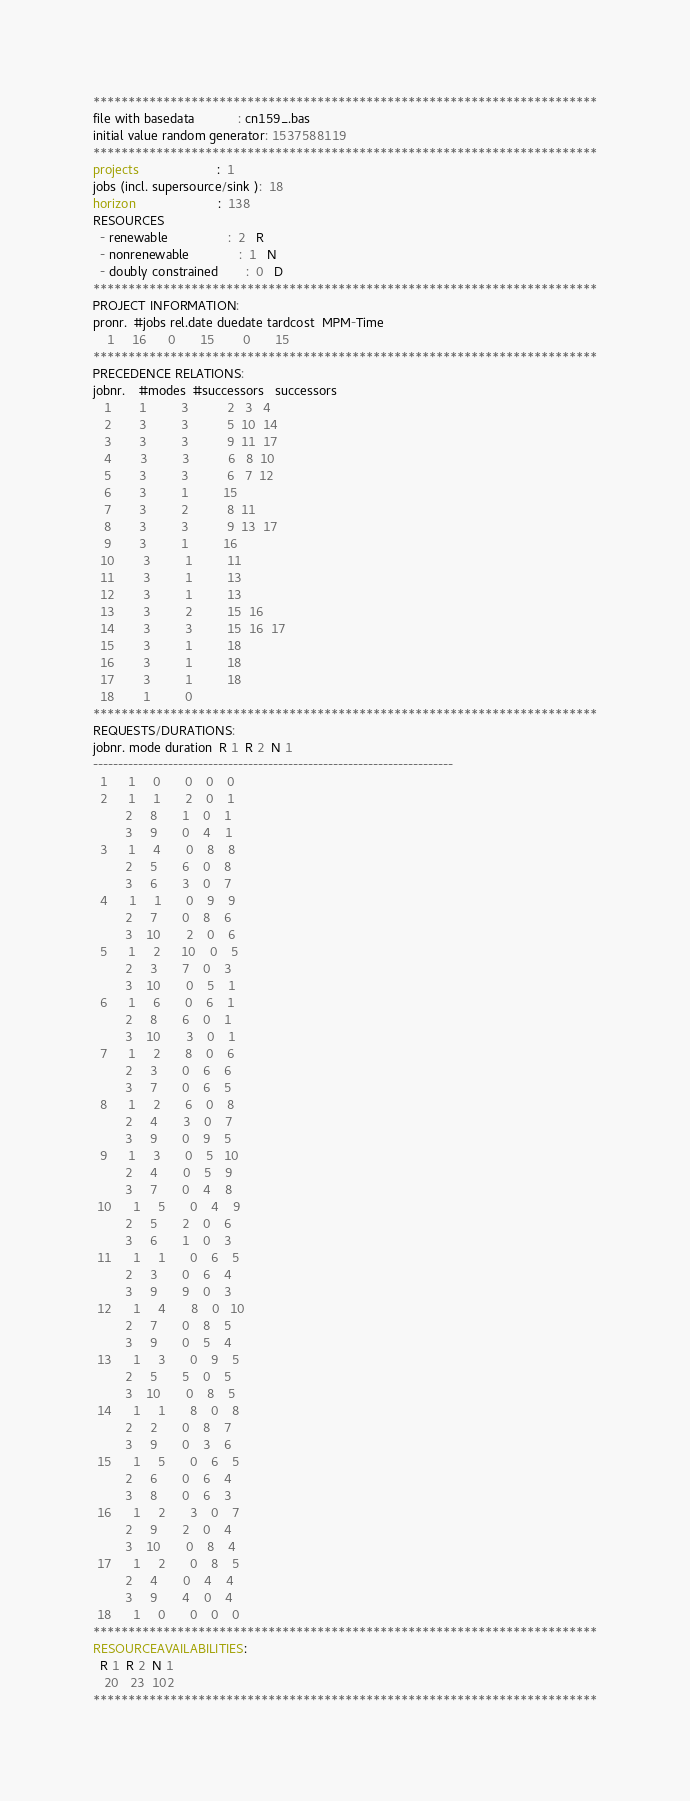<code> <loc_0><loc_0><loc_500><loc_500><_ObjectiveC_>************************************************************************
file with basedata            : cn159_.bas
initial value random generator: 1537588119
************************************************************************
projects                      :  1
jobs (incl. supersource/sink ):  18
horizon                       :  138
RESOURCES
  - renewable                 :  2   R
  - nonrenewable              :  1   N
  - doubly constrained        :  0   D
************************************************************************
PROJECT INFORMATION:
pronr.  #jobs rel.date duedate tardcost  MPM-Time
    1     16      0       15        0       15
************************************************************************
PRECEDENCE RELATIONS:
jobnr.    #modes  #successors   successors
   1        1          3           2   3   4
   2        3          3           5  10  14
   3        3          3           9  11  17
   4        3          3           6   8  10
   5        3          3           6   7  12
   6        3          1          15
   7        3          2           8  11
   8        3          3           9  13  17
   9        3          1          16
  10        3          1          11
  11        3          1          13
  12        3          1          13
  13        3          2          15  16
  14        3          3          15  16  17
  15        3          1          18
  16        3          1          18
  17        3          1          18
  18        1          0        
************************************************************************
REQUESTS/DURATIONS:
jobnr. mode duration  R 1  R 2  N 1
------------------------------------------------------------------------
  1      1     0       0    0    0
  2      1     1       2    0    1
         2     8       1    0    1
         3     9       0    4    1
  3      1     4       0    8    8
         2     5       6    0    8
         3     6       3    0    7
  4      1     1       0    9    9
         2     7       0    8    6
         3    10       2    0    6
  5      1     2      10    0    5
         2     3       7    0    3
         3    10       0    5    1
  6      1     6       0    6    1
         2     8       6    0    1
         3    10       3    0    1
  7      1     2       8    0    6
         2     3       0    6    6
         3     7       0    6    5
  8      1     2       6    0    8
         2     4       3    0    7
         3     9       0    9    5
  9      1     3       0    5   10
         2     4       0    5    9
         3     7       0    4    8
 10      1     5       0    4    9
         2     5       2    0    6
         3     6       1    0    3
 11      1     1       0    6    5
         2     3       0    6    4
         3     9       9    0    3
 12      1     4       8    0   10
         2     7       0    8    5
         3     9       0    5    4
 13      1     3       0    9    5
         2     5       5    0    5
         3    10       0    8    5
 14      1     1       8    0    8
         2     2       0    8    7
         3     9       0    3    6
 15      1     5       0    6    5
         2     6       0    6    4
         3     8       0    6    3
 16      1     2       3    0    7
         2     9       2    0    4
         3    10       0    8    4
 17      1     2       0    8    5
         2     4       0    4    4
         3     9       4    0    4
 18      1     0       0    0    0
************************************************************************
RESOURCEAVAILABILITIES:
  R 1  R 2  N 1
   20   23  102
************************************************************************
</code> 